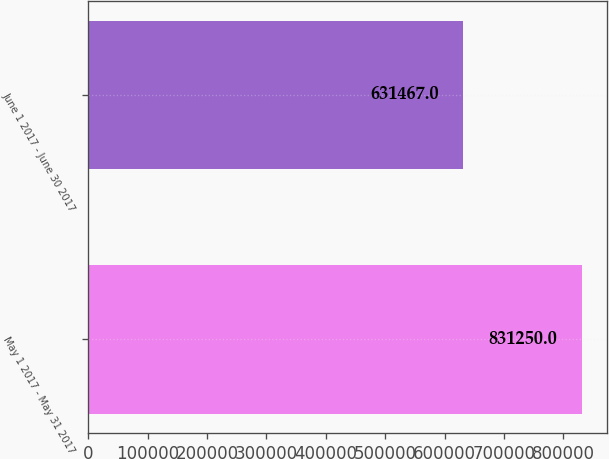Convert chart to OTSL. <chart><loc_0><loc_0><loc_500><loc_500><bar_chart><fcel>May 1 2017 - May 31 2017<fcel>June 1 2017 - June 30 2017<nl><fcel>831250<fcel>631467<nl></chart> 